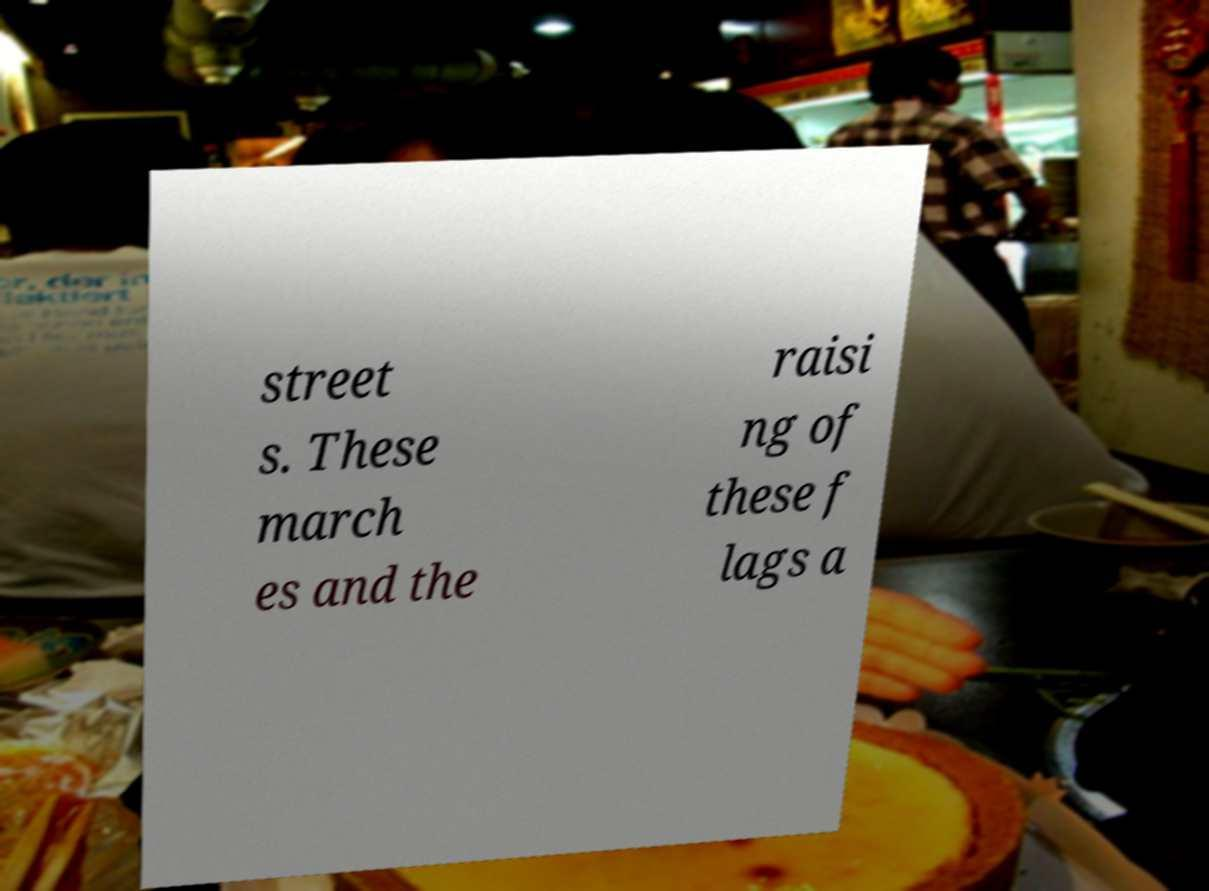For documentation purposes, I need the text within this image transcribed. Could you provide that? street s. These march es and the raisi ng of these f lags a 